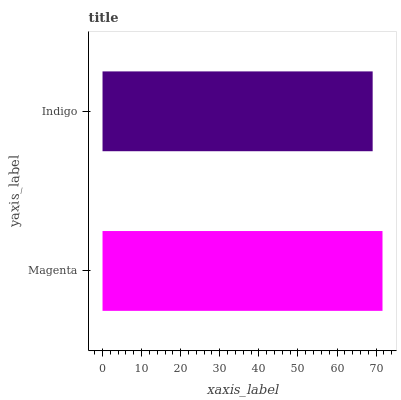Is Indigo the minimum?
Answer yes or no. Yes. Is Magenta the maximum?
Answer yes or no. Yes. Is Indigo the maximum?
Answer yes or no. No. Is Magenta greater than Indigo?
Answer yes or no. Yes. Is Indigo less than Magenta?
Answer yes or no. Yes. Is Indigo greater than Magenta?
Answer yes or no. No. Is Magenta less than Indigo?
Answer yes or no. No. Is Magenta the high median?
Answer yes or no. Yes. Is Indigo the low median?
Answer yes or no. Yes. Is Indigo the high median?
Answer yes or no. No. Is Magenta the low median?
Answer yes or no. No. 